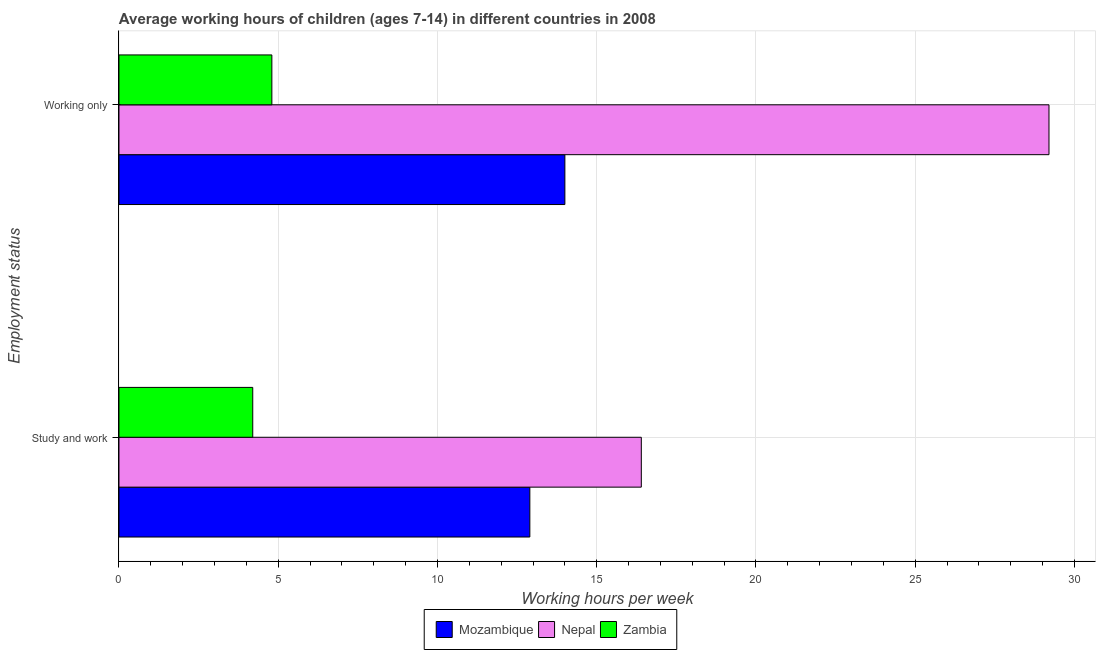How many different coloured bars are there?
Offer a terse response. 3. How many groups of bars are there?
Provide a succinct answer. 2. Are the number of bars on each tick of the Y-axis equal?
Offer a very short reply. Yes. How many bars are there on the 1st tick from the top?
Provide a succinct answer. 3. What is the label of the 2nd group of bars from the top?
Your response must be concise. Study and work. What is the average working hour of children involved in only work in Zambia?
Offer a very short reply. 4.8. Across all countries, what is the maximum average working hour of children involved in only work?
Make the answer very short. 29.2. In which country was the average working hour of children involved in only work maximum?
Ensure brevity in your answer.  Nepal. In which country was the average working hour of children involved in only work minimum?
Provide a succinct answer. Zambia. What is the difference between the average working hour of children involved in study and work in Nepal and that in Mozambique?
Offer a terse response. 3.5. What is the average average working hour of children involved in study and work per country?
Give a very brief answer. 11.17. What is the difference between the average working hour of children involved in only work and average working hour of children involved in study and work in Zambia?
Ensure brevity in your answer.  0.6. What is the ratio of the average working hour of children involved in study and work in Mozambique to that in Zambia?
Keep it short and to the point. 3.07. In how many countries, is the average working hour of children involved in only work greater than the average average working hour of children involved in only work taken over all countries?
Give a very brief answer. 1. What does the 2nd bar from the top in Working only represents?
Provide a succinct answer. Nepal. What does the 1st bar from the bottom in Working only represents?
Your response must be concise. Mozambique. Are all the bars in the graph horizontal?
Your response must be concise. Yes. How many countries are there in the graph?
Provide a short and direct response. 3. Are the values on the major ticks of X-axis written in scientific E-notation?
Offer a very short reply. No. Does the graph contain grids?
Provide a short and direct response. Yes. Where does the legend appear in the graph?
Offer a very short reply. Bottom center. How many legend labels are there?
Your answer should be very brief. 3. What is the title of the graph?
Provide a short and direct response. Average working hours of children (ages 7-14) in different countries in 2008. Does "Timor-Leste" appear as one of the legend labels in the graph?
Ensure brevity in your answer.  No. What is the label or title of the X-axis?
Your answer should be very brief. Working hours per week. What is the label or title of the Y-axis?
Provide a succinct answer. Employment status. What is the Working hours per week of Nepal in Study and work?
Your answer should be very brief. 16.4. What is the Working hours per week of Mozambique in Working only?
Ensure brevity in your answer.  14. What is the Working hours per week in Nepal in Working only?
Provide a short and direct response. 29.2. Across all Employment status, what is the maximum Working hours per week in Mozambique?
Provide a short and direct response. 14. Across all Employment status, what is the maximum Working hours per week of Nepal?
Offer a very short reply. 29.2. Across all Employment status, what is the minimum Working hours per week of Mozambique?
Keep it short and to the point. 12.9. Across all Employment status, what is the minimum Working hours per week of Zambia?
Provide a short and direct response. 4.2. What is the total Working hours per week of Mozambique in the graph?
Your response must be concise. 26.9. What is the total Working hours per week in Nepal in the graph?
Make the answer very short. 45.6. What is the total Working hours per week of Zambia in the graph?
Keep it short and to the point. 9. What is the difference between the Working hours per week in Mozambique in Study and work and that in Working only?
Make the answer very short. -1.1. What is the difference between the Working hours per week in Nepal in Study and work and that in Working only?
Provide a short and direct response. -12.8. What is the difference between the Working hours per week in Mozambique in Study and work and the Working hours per week in Nepal in Working only?
Make the answer very short. -16.3. What is the difference between the Working hours per week of Mozambique in Study and work and the Working hours per week of Zambia in Working only?
Keep it short and to the point. 8.1. What is the difference between the Working hours per week of Nepal in Study and work and the Working hours per week of Zambia in Working only?
Offer a terse response. 11.6. What is the average Working hours per week in Mozambique per Employment status?
Offer a terse response. 13.45. What is the average Working hours per week of Nepal per Employment status?
Make the answer very short. 22.8. What is the average Working hours per week of Zambia per Employment status?
Make the answer very short. 4.5. What is the difference between the Working hours per week of Mozambique and Working hours per week of Nepal in Study and work?
Your answer should be very brief. -3.5. What is the difference between the Working hours per week of Mozambique and Working hours per week of Nepal in Working only?
Make the answer very short. -15.2. What is the difference between the Working hours per week in Mozambique and Working hours per week in Zambia in Working only?
Keep it short and to the point. 9.2. What is the difference between the Working hours per week of Nepal and Working hours per week of Zambia in Working only?
Provide a succinct answer. 24.4. What is the ratio of the Working hours per week in Mozambique in Study and work to that in Working only?
Your answer should be compact. 0.92. What is the ratio of the Working hours per week of Nepal in Study and work to that in Working only?
Your response must be concise. 0.56. What is the ratio of the Working hours per week in Zambia in Study and work to that in Working only?
Provide a succinct answer. 0.88. What is the difference between the highest and the second highest Working hours per week in Mozambique?
Provide a succinct answer. 1.1. What is the difference between the highest and the second highest Working hours per week of Nepal?
Provide a short and direct response. 12.8. What is the difference between the highest and the second highest Working hours per week in Zambia?
Your response must be concise. 0.6. What is the difference between the highest and the lowest Working hours per week in Mozambique?
Give a very brief answer. 1.1. What is the difference between the highest and the lowest Working hours per week in Nepal?
Your answer should be compact. 12.8. 